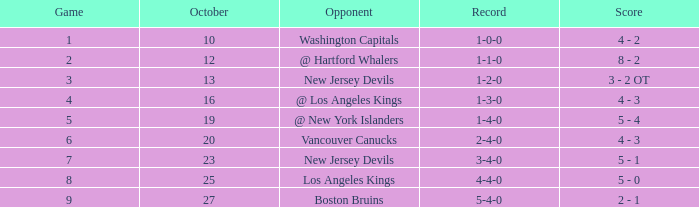What was the average game with a record of 4-4-0? 8.0. 